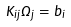<formula> <loc_0><loc_0><loc_500><loc_500>K _ { i j } \Omega _ { j } = b _ { i }</formula> 